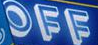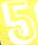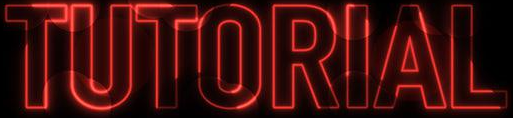Transcribe the words shown in these images in order, separated by a semicolon. OFF; 5; TUTORIAL 